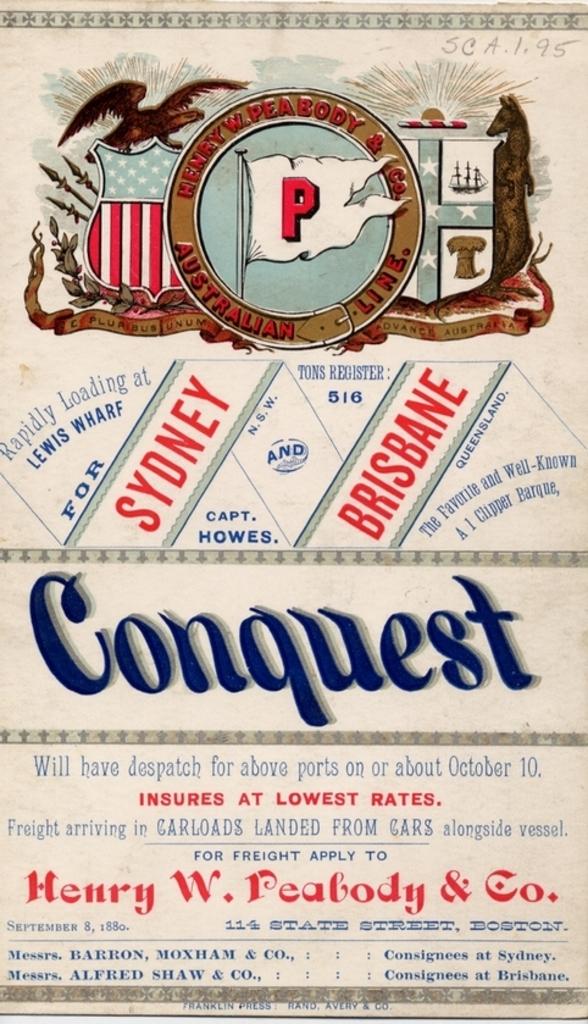What is the first city mentioned?
Keep it short and to the point. Sydney. Who do you apply to?
Offer a very short reply. Henry w. peabody & co. 